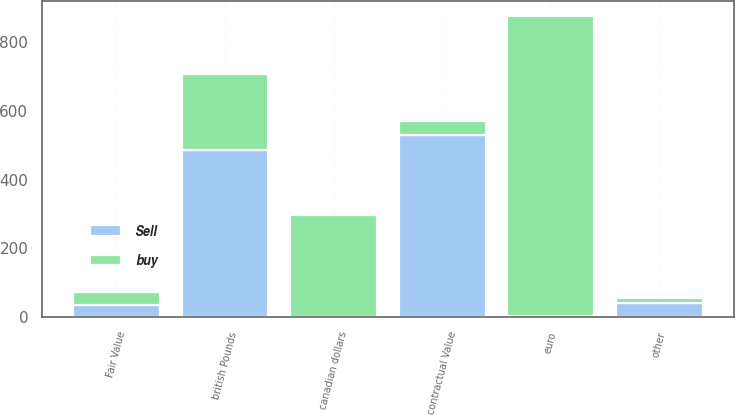Convert chart. <chart><loc_0><loc_0><loc_500><loc_500><stacked_bar_chart><ecel><fcel>british Pounds<fcel>canadian dollars<fcel>euro<fcel>other<fcel>contractual Value<fcel>Fair Value<nl><fcel>Sell<fcel>485.6<fcel>1.2<fcel>3.6<fcel>40.6<fcel>531<fcel>35.9<nl><fcel>buy<fcel>221.7<fcel>296.7<fcel>871.2<fcel>14.4<fcel>40.6<fcel>36.7<nl></chart> 